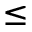Convert formula to latex. <formula><loc_0><loc_0><loc_500><loc_500>\leq</formula> 